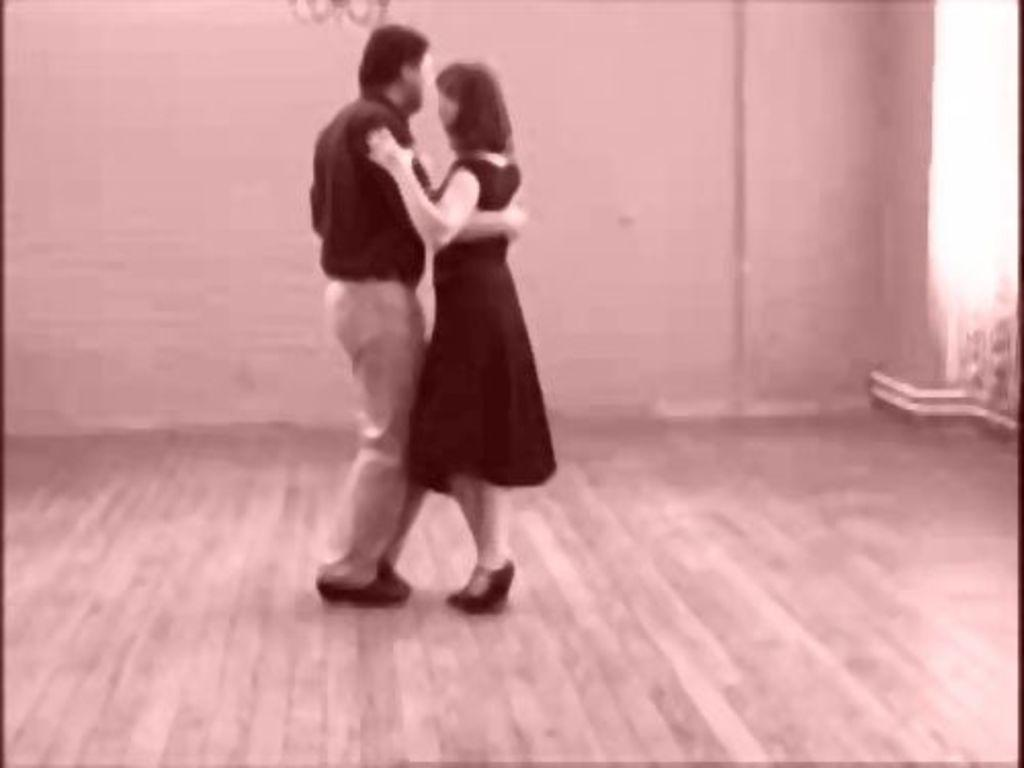What is the man in the image wearing? The man is wearing a black shirt and cream pants. What is the woman in the image wearing? The woman is wearing a black top. What activity is the man and woman engaged in? The man and woman are dancing together. What type of flooring is visible at the bottom of the image? There is wooden flooring at the bottom of the image. What word is being used to attack the man in the image? There is no word or attack present in the image; it features a man and a woman dancing together on a wooden floor. 